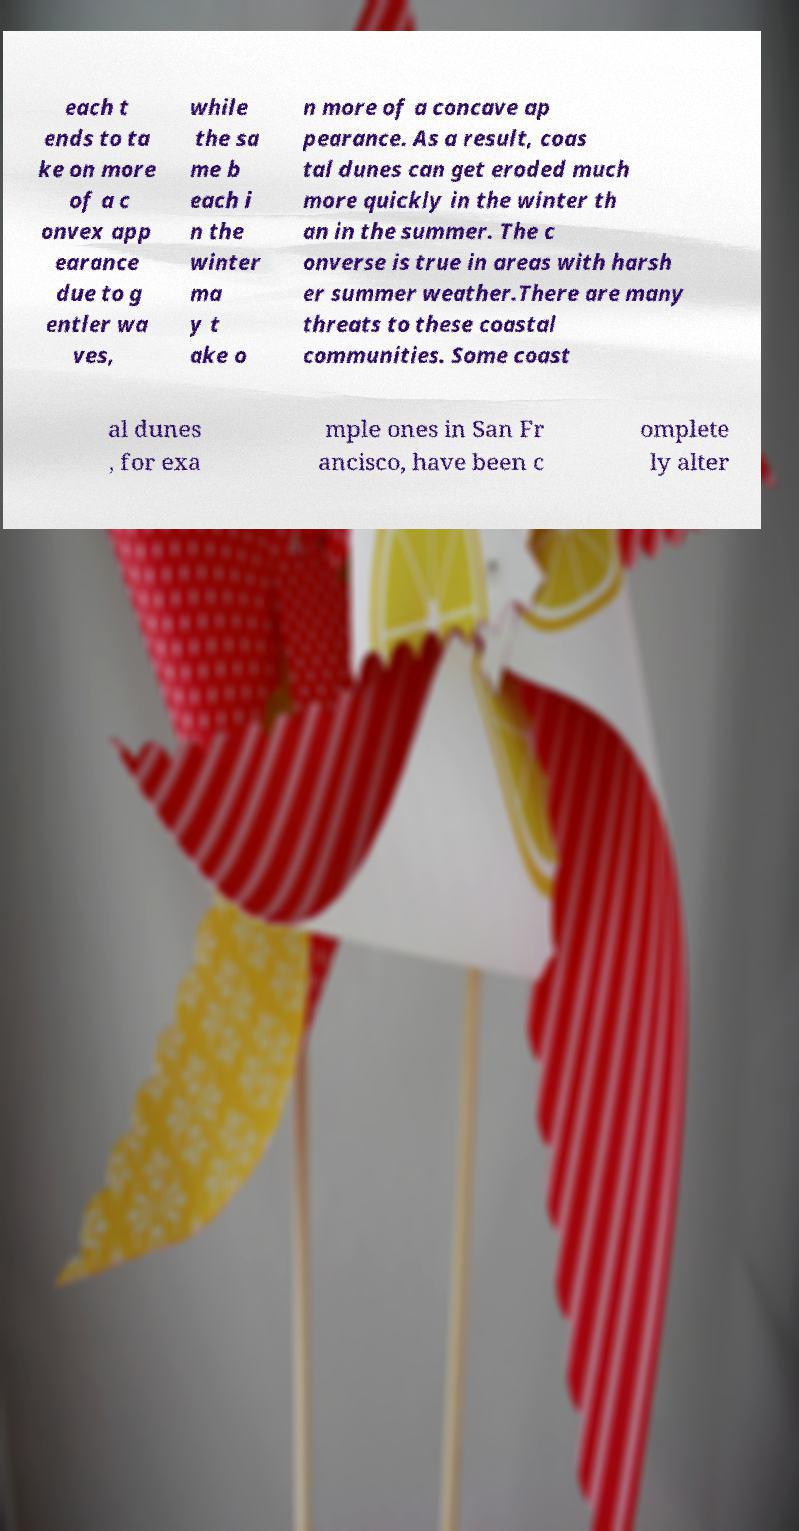Please identify and transcribe the text found in this image. each t ends to ta ke on more of a c onvex app earance due to g entler wa ves, while the sa me b each i n the winter ma y t ake o n more of a concave ap pearance. As a result, coas tal dunes can get eroded much more quickly in the winter th an in the summer. The c onverse is true in areas with harsh er summer weather.There are many threats to these coastal communities. Some coast al dunes , for exa mple ones in San Fr ancisco, have been c omplete ly alter 